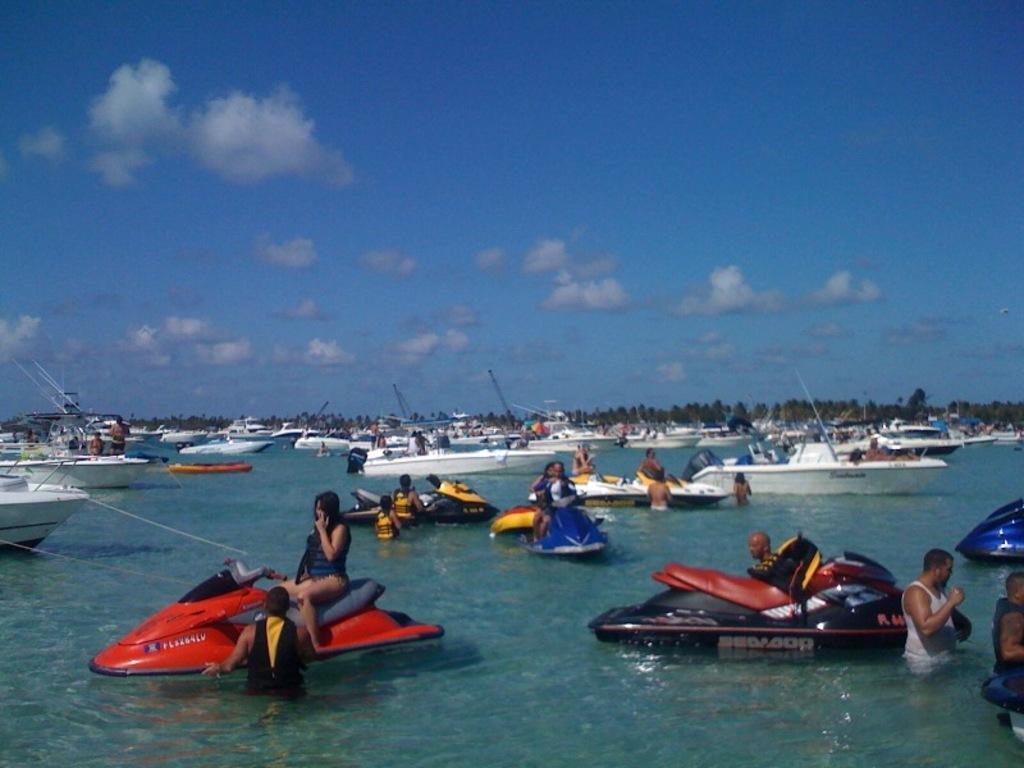Can you describe this image briefly? In this image we can see some boats. Few people are sitting in the boats. Few people are swimming and we can also see trees, water and sky. 